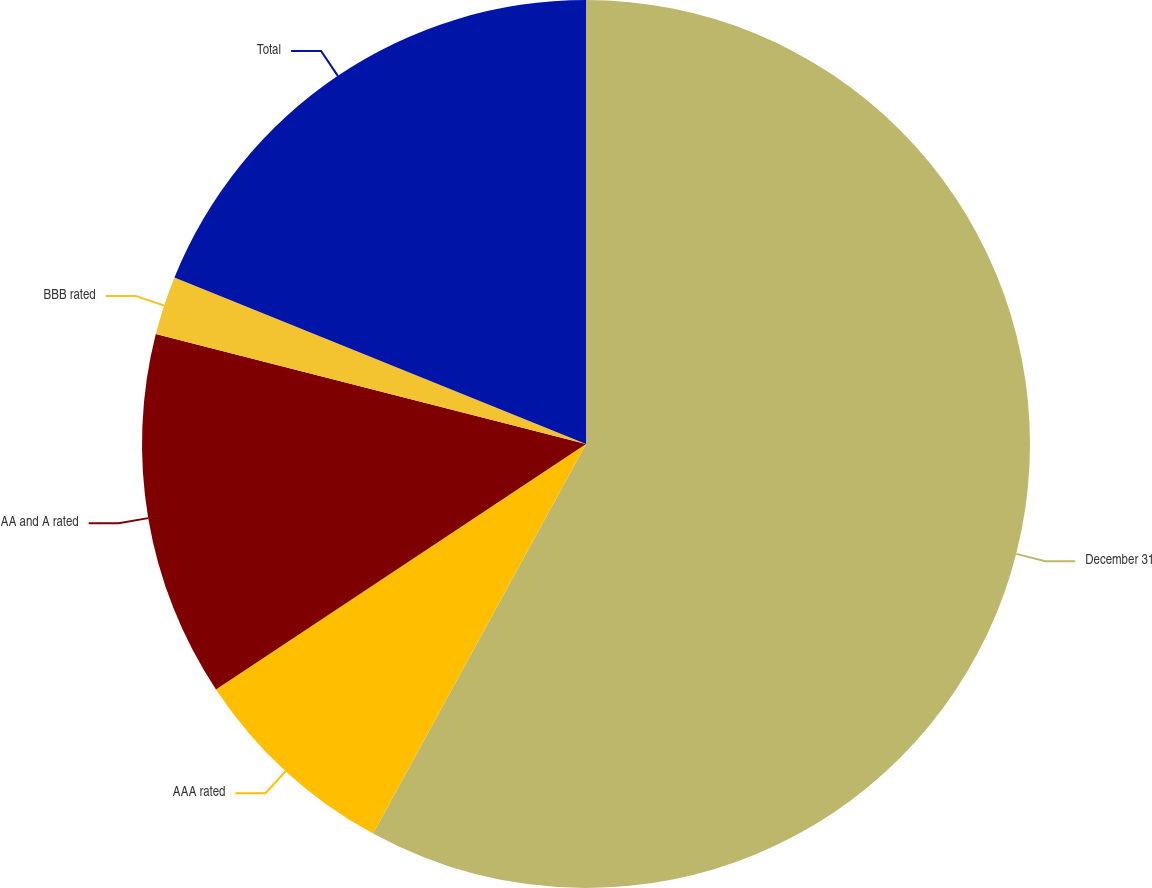Convert chart. <chart><loc_0><loc_0><loc_500><loc_500><pie_chart><fcel>December 31<fcel>AAA rated<fcel>AA and A rated<fcel>BBB rated<fcel>Total<nl><fcel>57.96%<fcel>7.72%<fcel>13.3%<fcel>2.14%<fcel>18.88%<nl></chart> 